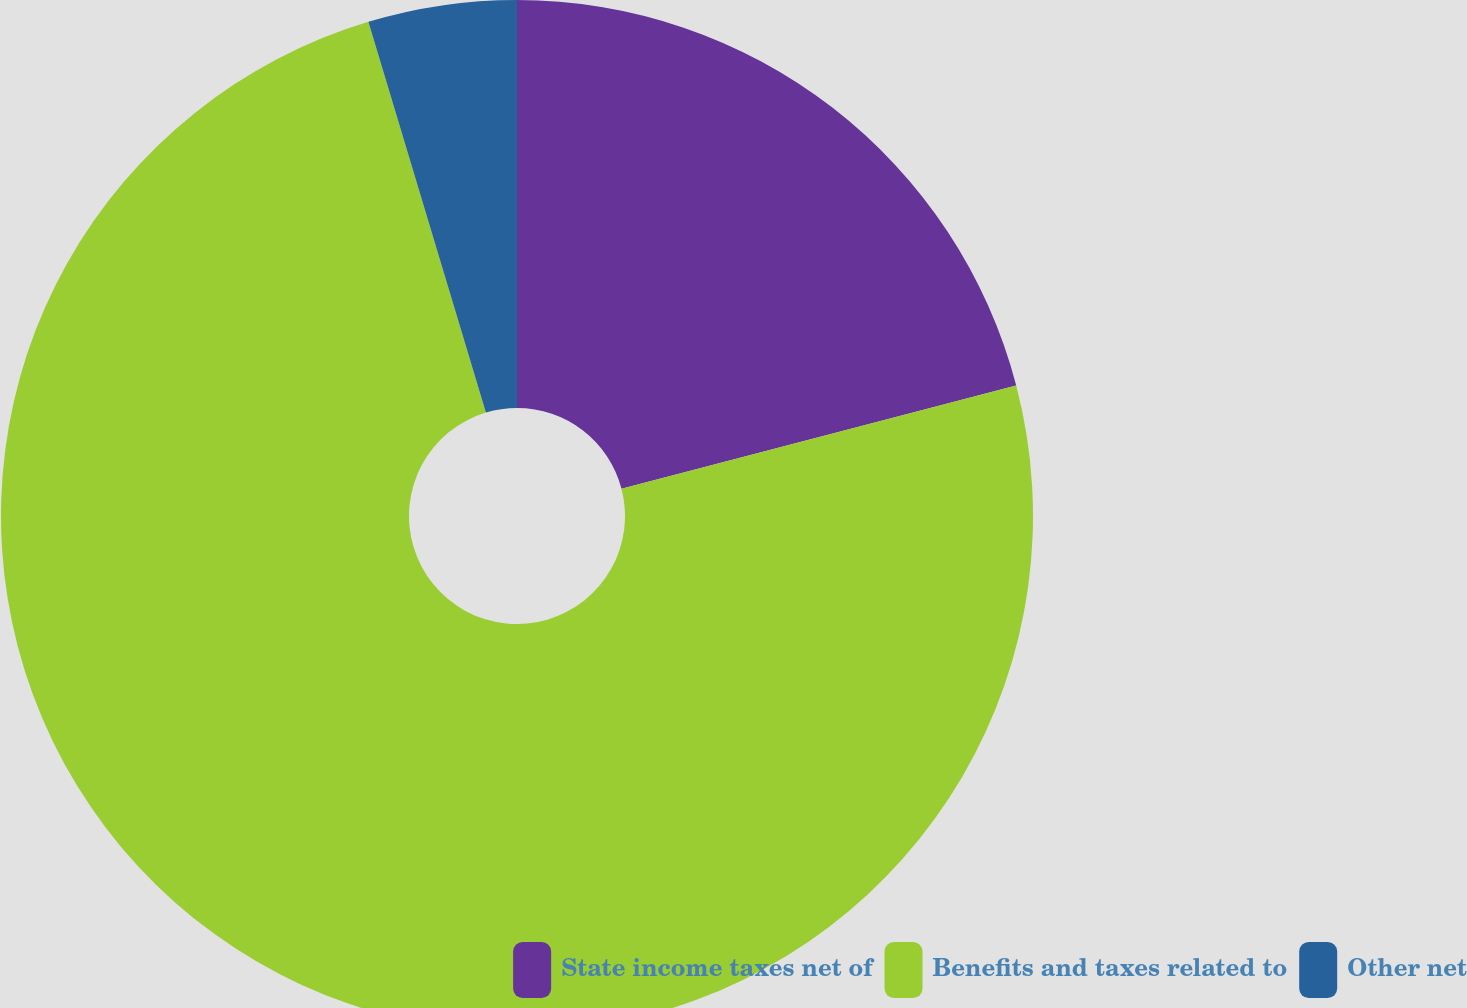Convert chart to OTSL. <chart><loc_0><loc_0><loc_500><loc_500><pie_chart><fcel>State income taxes net of<fcel>Benefits and taxes related to<fcel>Other net<nl><fcel>20.93%<fcel>74.42%<fcel>4.65%<nl></chart> 